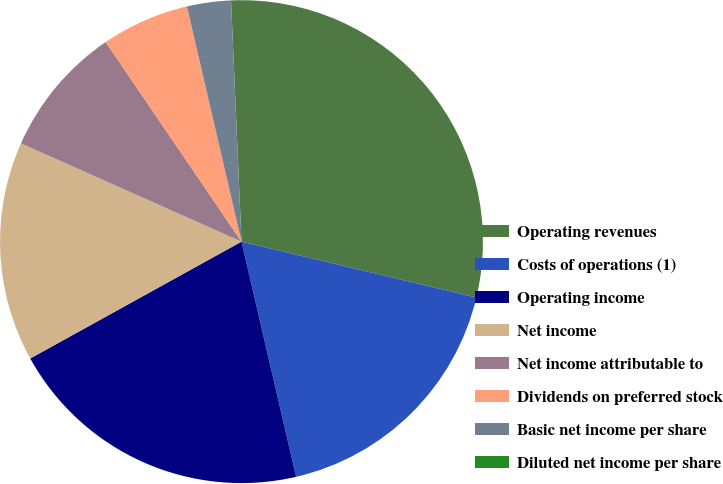<chart> <loc_0><loc_0><loc_500><loc_500><pie_chart><fcel>Operating revenues<fcel>Costs of operations (1)<fcel>Operating income<fcel>Net income<fcel>Net income attributable to<fcel>Dividends on preferred stock<fcel>Basic net income per share<fcel>Diluted net income per share<nl><fcel>29.41%<fcel>17.65%<fcel>20.59%<fcel>14.71%<fcel>8.82%<fcel>5.88%<fcel>2.94%<fcel>0.0%<nl></chart> 